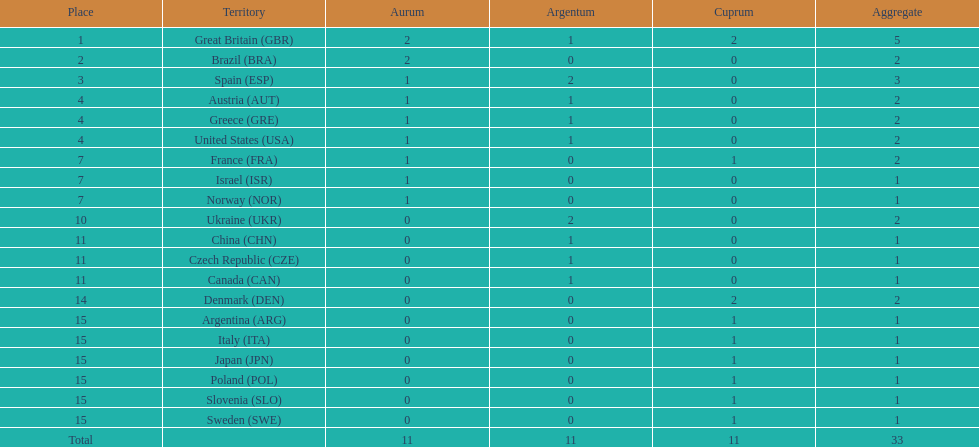How many gold medals did italy receive? 0. Could you help me parse every detail presented in this table? {'header': ['Place', 'Territory', 'Aurum', 'Argentum', 'Cuprum', 'Aggregate'], 'rows': [['1', 'Great Britain\xa0(GBR)', '2', '1', '2', '5'], ['2', 'Brazil\xa0(BRA)', '2', '0', '0', '2'], ['3', 'Spain\xa0(ESP)', '1', '2', '0', '3'], ['4', 'Austria\xa0(AUT)', '1', '1', '0', '2'], ['4', 'Greece\xa0(GRE)', '1', '1', '0', '2'], ['4', 'United States\xa0(USA)', '1', '1', '0', '2'], ['7', 'France\xa0(FRA)', '1', '0', '1', '2'], ['7', 'Israel\xa0(ISR)', '1', '0', '0', '1'], ['7', 'Norway\xa0(NOR)', '1', '0', '0', '1'], ['10', 'Ukraine\xa0(UKR)', '0', '2', '0', '2'], ['11', 'China\xa0(CHN)', '0', '1', '0', '1'], ['11', 'Czech Republic\xa0(CZE)', '0', '1', '0', '1'], ['11', 'Canada\xa0(CAN)', '0', '1', '0', '1'], ['14', 'Denmark\xa0(DEN)', '0', '0', '2', '2'], ['15', 'Argentina\xa0(ARG)', '0', '0', '1', '1'], ['15', 'Italy\xa0(ITA)', '0', '0', '1', '1'], ['15', 'Japan\xa0(JPN)', '0', '0', '1', '1'], ['15', 'Poland\xa0(POL)', '0', '0', '1', '1'], ['15', 'Slovenia\xa0(SLO)', '0', '0', '1', '1'], ['15', 'Sweden\xa0(SWE)', '0', '0', '1', '1'], ['Total', '', '11', '11', '11', '33']]} 